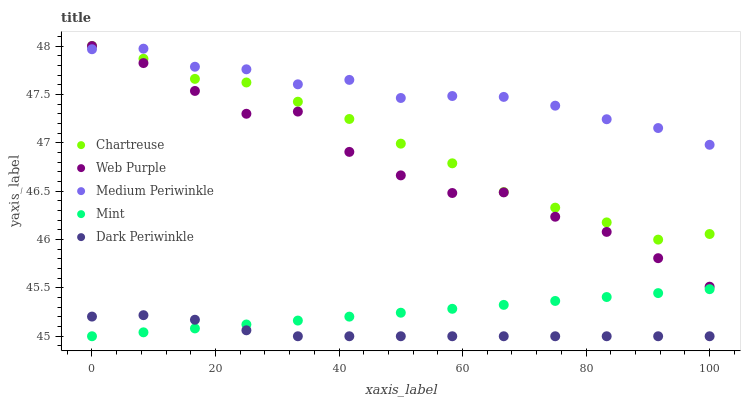Does Dark Periwinkle have the minimum area under the curve?
Answer yes or no. Yes. Does Medium Periwinkle have the maximum area under the curve?
Answer yes or no. Yes. Does Chartreuse have the minimum area under the curve?
Answer yes or no. No. Does Chartreuse have the maximum area under the curve?
Answer yes or no. No. Is Mint the smoothest?
Answer yes or no. Yes. Is Web Purple the roughest?
Answer yes or no. Yes. Is Chartreuse the smoothest?
Answer yes or no. No. Is Chartreuse the roughest?
Answer yes or no. No. Does Mint have the lowest value?
Answer yes or no. Yes. Does Chartreuse have the lowest value?
Answer yes or no. No. Does Web Purple have the highest value?
Answer yes or no. Yes. Does Medium Periwinkle have the highest value?
Answer yes or no. No. Is Dark Periwinkle less than Web Purple?
Answer yes or no. Yes. Is Chartreuse greater than Dark Periwinkle?
Answer yes or no. Yes. Does Mint intersect Dark Periwinkle?
Answer yes or no. Yes. Is Mint less than Dark Periwinkle?
Answer yes or no. No. Is Mint greater than Dark Periwinkle?
Answer yes or no. No. Does Dark Periwinkle intersect Web Purple?
Answer yes or no. No. 